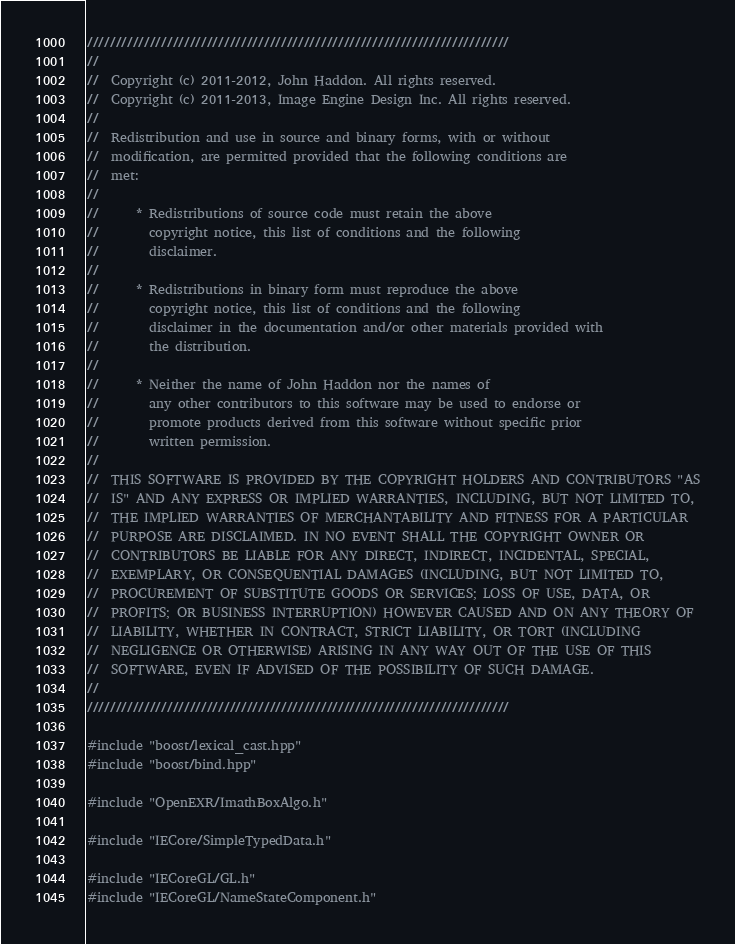<code> <loc_0><loc_0><loc_500><loc_500><_C++_>//////////////////////////////////////////////////////////////////////////
//  
//  Copyright (c) 2011-2012, John Haddon. All rights reserved.
//  Copyright (c) 2011-2013, Image Engine Design Inc. All rights reserved.
//  
//  Redistribution and use in source and binary forms, with or without
//  modification, are permitted provided that the following conditions are
//  met:
//  
//      * Redistributions of source code must retain the above
//        copyright notice, this list of conditions and the following
//        disclaimer.
//  
//      * Redistributions in binary form must reproduce the above
//        copyright notice, this list of conditions and the following
//        disclaimer in the documentation and/or other materials provided with
//        the distribution.
//  
//      * Neither the name of John Haddon nor the names of
//        any other contributors to this software may be used to endorse or
//        promote products derived from this software without specific prior
//        written permission.
//  
//  THIS SOFTWARE IS PROVIDED BY THE COPYRIGHT HOLDERS AND CONTRIBUTORS "AS
//  IS" AND ANY EXPRESS OR IMPLIED WARRANTIES, INCLUDING, BUT NOT LIMITED TO,
//  THE IMPLIED WARRANTIES OF MERCHANTABILITY AND FITNESS FOR A PARTICULAR
//  PURPOSE ARE DISCLAIMED. IN NO EVENT SHALL THE COPYRIGHT OWNER OR
//  CONTRIBUTORS BE LIABLE FOR ANY DIRECT, INDIRECT, INCIDENTAL, SPECIAL,
//  EXEMPLARY, OR CONSEQUENTIAL DAMAGES (INCLUDING, BUT NOT LIMITED TO,
//  PROCUREMENT OF SUBSTITUTE GOODS OR SERVICES; LOSS OF USE, DATA, OR
//  PROFITS; OR BUSINESS INTERRUPTION) HOWEVER CAUSED AND ON ANY THEORY OF
//  LIABILITY, WHETHER IN CONTRACT, STRICT LIABILITY, OR TORT (INCLUDING
//  NEGLIGENCE OR OTHERWISE) ARISING IN ANY WAY OUT OF THE USE OF THIS
//  SOFTWARE, EVEN IF ADVISED OF THE POSSIBILITY OF SUCH DAMAGE.
//  
//////////////////////////////////////////////////////////////////////////

#include "boost/lexical_cast.hpp"
#include "boost/bind.hpp"

#include "OpenEXR/ImathBoxAlgo.h"

#include "IECore/SimpleTypedData.h"

#include "IECoreGL/GL.h"
#include "IECoreGL/NameStateComponent.h"</code> 